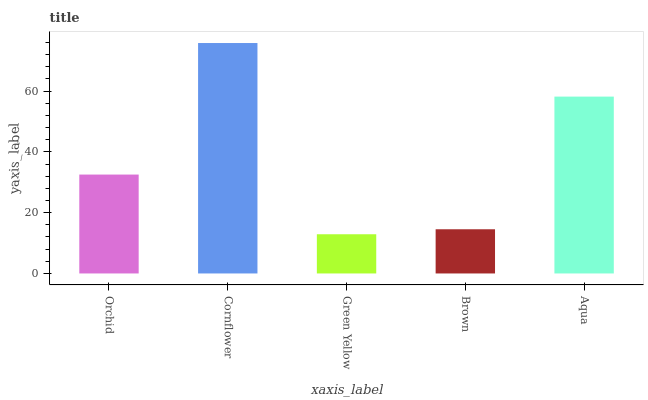Is Green Yellow the minimum?
Answer yes or no. Yes. Is Cornflower the maximum?
Answer yes or no. Yes. Is Cornflower the minimum?
Answer yes or no. No. Is Green Yellow the maximum?
Answer yes or no. No. Is Cornflower greater than Green Yellow?
Answer yes or no. Yes. Is Green Yellow less than Cornflower?
Answer yes or no. Yes. Is Green Yellow greater than Cornflower?
Answer yes or no. No. Is Cornflower less than Green Yellow?
Answer yes or no. No. Is Orchid the high median?
Answer yes or no. Yes. Is Orchid the low median?
Answer yes or no. Yes. Is Green Yellow the high median?
Answer yes or no. No. Is Cornflower the low median?
Answer yes or no. No. 